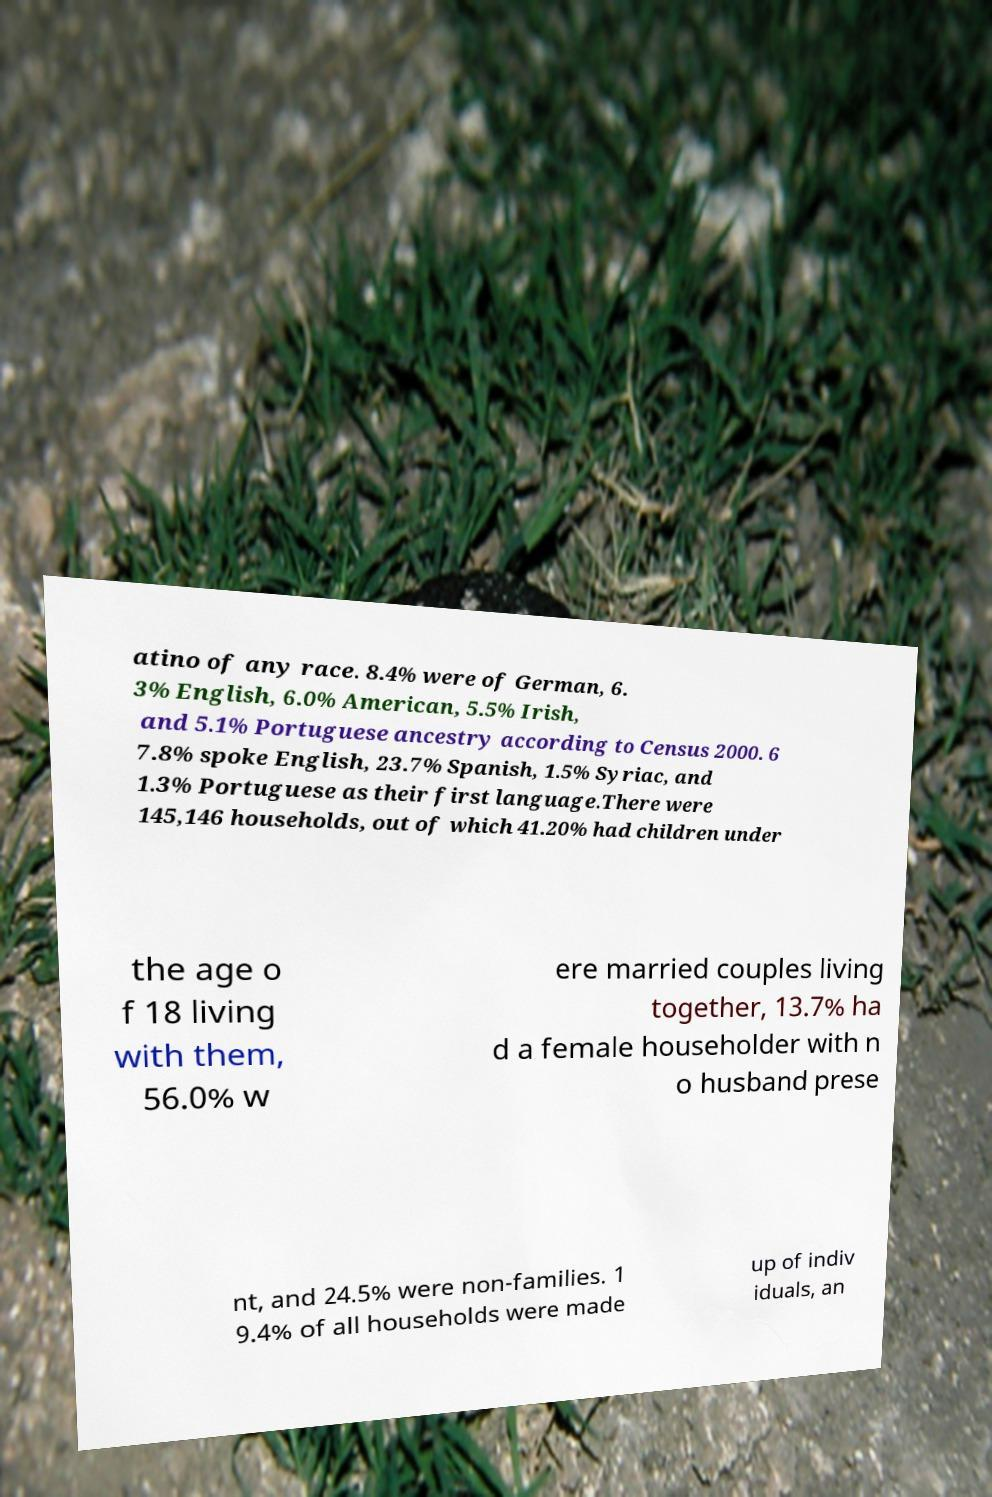For documentation purposes, I need the text within this image transcribed. Could you provide that? atino of any race. 8.4% were of German, 6. 3% English, 6.0% American, 5.5% Irish, and 5.1% Portuguese ancestry according to Census 2000. 6 7.8% spoke English, 23.7% Spanish, 1.5% Syriac, and 1.3% Portuguese as their first language.There were 145,146 households, out of which 41.20% had children under the age o f 18 living with them, 56.0% w ere married couples living together, 13.7% ha d a female householder with n o husband prese nt, and 24.5% were non-families. 1 9.4% of all households were made up of indiv iduals, an 